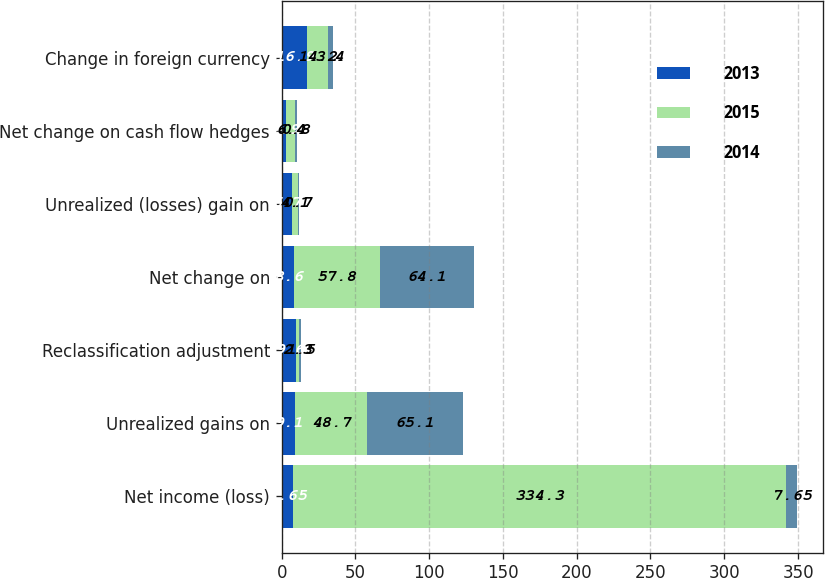<chart> <loc_0><loc_0><loc_500><loc_500><stacked_bar_chart><ecel><fcel>Net income (loss)<fcel>Unrealized gains on<fcel>Reclassification adjustment<fcel>Net change on<fcel>Unrealized (losses) gain on<fcel>Net change on cash flow hedges<fcel>Change in foreign currency<nl><fcel>2013<fcel>7.65<fcel>9.1<fcel>9.6<fcel>8.6<fcel>6.7<fcel>2.9<fcel>16.9<nl><fcel>2015<fcel>334.3<fcel>48.7<fcel>2.3<fcel>57.8<fcel>4.1<fcel>6.4<fcel>14.2<nl><fcel>2014<fcel>7.65<fcel>65.1<fcel>1.5<fcel>64.1<fcel>0.7<fcel>0.8<fcel>3.4<nl></chart> 